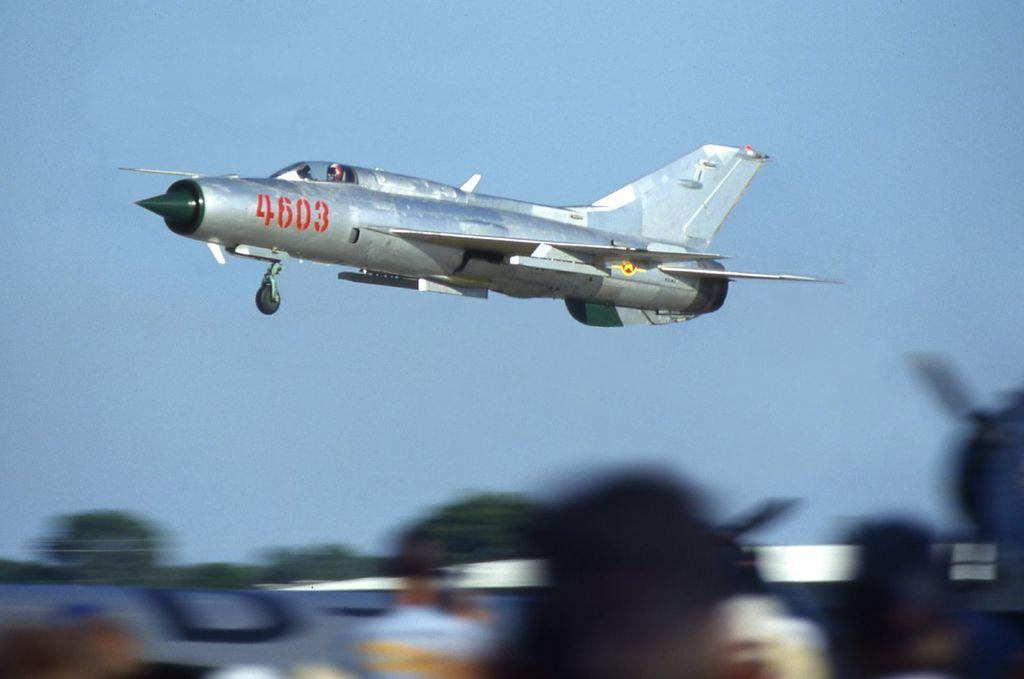What is the main subject of the image? The main subject of the image is an aircraft. Can you describe the position of the aircraft in the image? The aircraft is in the air in the image. How is the front image of the aircraft depicted? The front image of the aircraft is blurry in the image. What can be seen in the background of the image? The sky is visible in the background of the image. What type of dress is the aircraft wearing in the image? Aircrafts do not wear dresses, as they are inanimate objects and not human beings. 